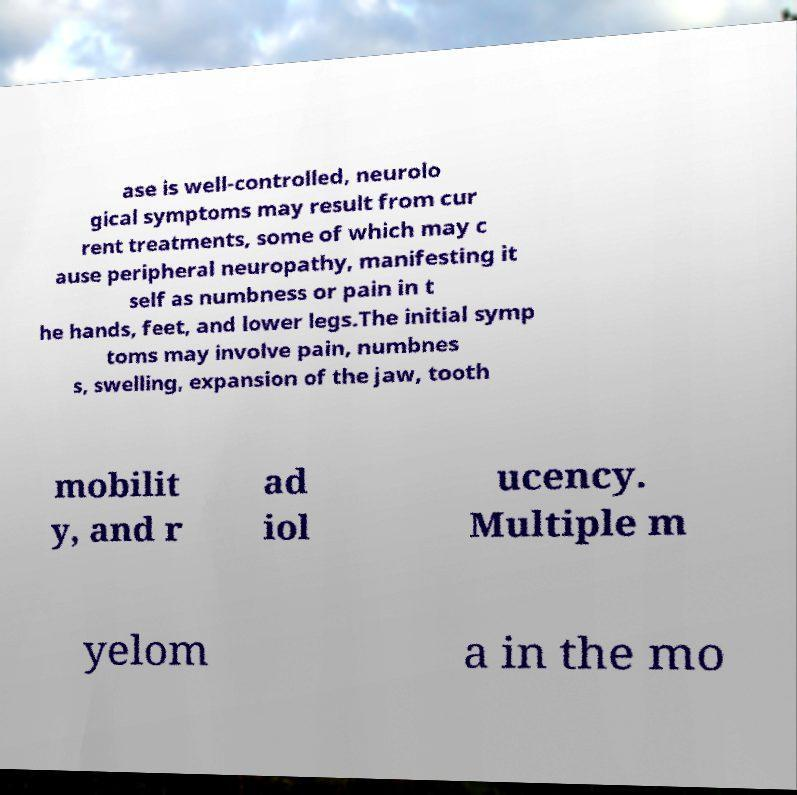Can you read and provide the text displayed in the image?This photo seems to have some interesting text. Can you extract and type it out for me? ase is well-controlled, neurolo gical symptoms may result from cur rent treatments, some of which may c ause peripheral neuropathy, manifesting it self as numbness or pain in t he hands, feet, and lower legs.The initial symp toms may involve pain, numbnes s, swelling, expansion of the jaw, tooth mobilit y, and r ad iol ucency. Multiple m yelom a in the mo 